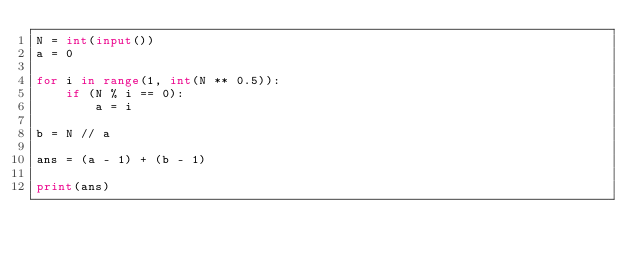<code> <loc_0><loc_0><loc_500><loc_500><_Python_>N = int(input())
a = 0

for i in range(1, int(N ** 0.5)):
    if (N % i == 0):
        a = i

b = N // a

ans = (a - 1) + (b - 1)

print(ans)

</code> 